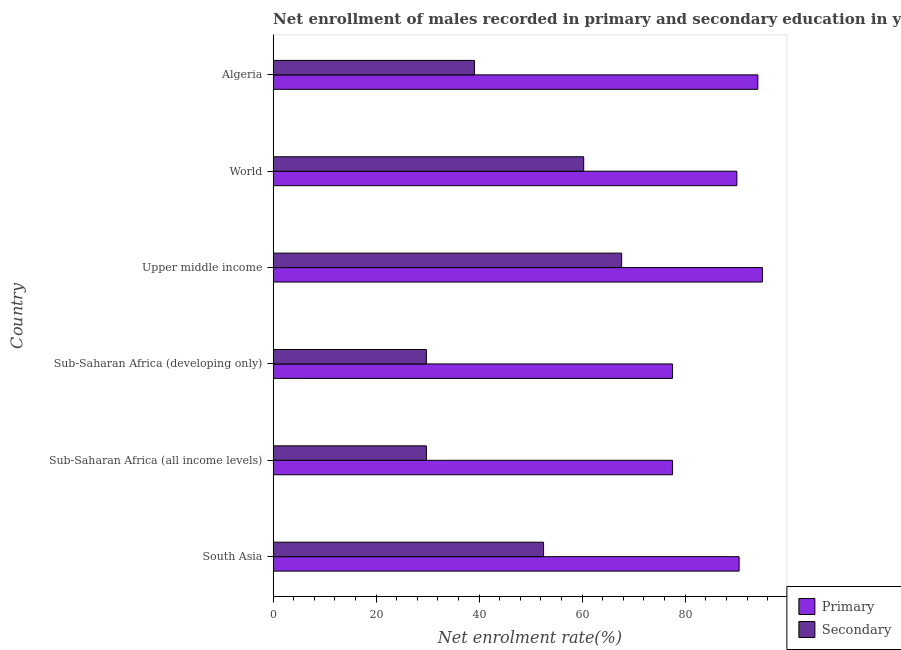How many different coloured bars are there?
Your answer should be very brief. 2. Are the number of bars per tick equal to the number of legend labels?
Your answer should be compact. Yes. Are the number of bars on each tick of the Y-axis equal?
Offer a terse response. Yes. How many bars are there on the 6th tick from the top?
Your answer should be compact. 2. How many bars are there on the 1st tick from the bottom?
Your response must be concise. 2. What is the label of the 5th group of bars from the top?
Your response must be concise. Sub-Saharan Africa (all income levels). In how many cases, is the number of bars for a given country not equal to the number of legend labels?
Make the answer very short. 0. What is the enrollment rate in primary education in World?
Your response must be concise. 90.03. Across all countries, what is the maximum enrollment rate in primary education?
Your answer should be very brief. 94.99. Across all countries, what is the minimum enrollment rate in secondary education?
Offer a very short reply. 29.75. In which country was the enrollment rate in secondary education maximum?
Your answer should be compact. Upper middle income. In which country was the enrollment rate in secondary education minimum?
Make the answer very short. Sub-Saharan Africa (developing only). What is the total enrollment rate in secondary education in the graph?
Provide a short and direct response. 279.05. What is the difference between the enrollment rate in secondary education in Algeria and that in Sub-Saharan Africa (developing only)?
Your answer should be compact. 9.33. What is the difference between the enrollment rate in primary education in Sub-Saharan Africa (developing only) and the enrollment rate in secondary education in Upper middle income?
Offer a very short reply. 9.88. What is the average enrollment rate in secondary education per country?
Your response must be concise. 46.51. What is the difference between the enrollment rate in primary education and enrollment rate in secondary education in Sub-Saharan Africa (all income levels)?
Your answer should be very brief. 47.77. What is the ratio of the enrollment rate in secondary education in Algeria to that in Upper middle income?
Your answer should be compact. 0.58. Is the enrollment rate in secondary education in Sub-Saharan Africa (all income levels) less than that in Sub-Saharan Africa (developing only)?
Provide a succinct answer. No. Is the difference between the enrollment rate in secondary education in Upper middle income and World greater than the difference between the enrollment rate in primary education in Upper middle income and World?
Make the answer very short. Yes. What is the difference between the highest and the second highest enrollment rate in secondary education?
Keep it short and to the point. 7.37. What is the difference between the highest and the lowest enrollment rate in secondary education?
Your answer should be very brief. 37.91. What does the 2nd bar from the top in South Asia represents?
Make the answer very short. Primary. What does the 1st bar from the bottom in South Asia represents?
Your answer should be very brief. Primary. How many bars are there?
Offer a terse response. 12. What is the difference between two consecutive major ticks on the X-axis?
Provide a short and direct response. 20. Are the values on the major ticks of X-axis written in scientific E-notation?
Offer a terse response. No. Where does the legend appear in the graph?
Keep it short and to the point. Bottom right. What is the title of the graph?
Offer a very short reply. Net enrollment of males recorded in primary and secondary education in year 2007. What is the label or title of the X-axis?
Offer a very short reply. Net enrolment rate(%). What is the Net enrolment rate(%) of Primary in South Asia?
Give a very brief answer. 90.47. What is the Net enrolment rate(%) in Secondary in South Asia?
Ensure brevity in your answer.  52.5. What is the Net enrolment rate(%) of Primary in Sub-Saharan Africa (all income levels)?
Your answer should be very brief. 77.53. What is the Net enrolment rate(%) in Secondary in Sub-Saharan Africa (all income levels)?
Keep it short and to the point. 29.75. What is the Net enrolment rate(%) in Primary in Sub-Saharan Africa (developing only)?
Your answer should be very brief. 77.54. What is the Net enrolment rate(%) of Secondary in Sub-Saharan Africa (developing only)?
Your answer should be compact. 29.75. What is the Net enrolment rate(%) in Primary in Upper middle income?
Keep it short and to the point. 94.99. What is the Net enrolment rate(%) of Secondary in Upper middle income?
Make the answer very short. 67.66. What is the Net enrolment rate(%) of Primary in World?
Your answer should be compact. 90.03. What is the Net enrolment rate(%) in Secondary in World?
Your response must be concise. 60.29. What is the Net enrolment rate(%) of Primary in Algeria?
Offer a terse response. 94.11. What is the Net enrolment rate(%) of Secondary in Algeria?
Make the answer very short. 39.08. Across all countries, what is the maximum Net enrolment rate(%) in Primary?
Your response must be concise. 94.99. Across all countries, what is the maximum Net enrolment rate(%) in Secondary?
Your answer should be compact. 67.66. Across all countries, what is the minimum Net enrolment rate(%) in Primary?
Ensure brevity in your answer.  77.53. Across all countries, what is the minimum Net enrolment rate(%) in Secondary?
Give a very brief answer. 29.75. What is the total Net enrolment rate(%) of Primary in the graph?
Your answer should be very brief. 524.66. What is the total Net enrolment rate(%) in Secondary in the graph?
Offer a terse response. 279.05. What is the difference between the Net enrolment rate(%) in Primary in South Asia and that in Sub-Saharan Africa (all income levels)?
Offer a very short reply. 12.94. What is the difference between the Net enrolment rate(%) of Secondary in South Asia and that in Sub-Saharan Africa (all income levels)?
Your response must be concise. 22.75. What is the difference between the Net enrolment rate(%) of Primary in South Asia and that in Sub-Saharan Africa (developing only)?
Ensure brevity in your answer.  12.93. What is the difference between the Net enrolment rate(%) of Secondary in South Asia and that in Sub-Saharan Africa (developing only)?
Make the answer very short. 22.75. What is the difference between the Net enrolment rate(%) in Primary in South Asia and that in Upper middle income?
Give a very brief answer. -4.52. What is the difference between the Net enrolment rate(%) in Secondary in South Asia and that in Upper middle income?
Your response must be concise. -15.16. What is the difference between the Net enrolment rate(%) in Primary in South Asia and that in World?
Give a very brief answer. 0.44. What is the difference between the Net enrolment rate(%) in Secondary in South Asia and that in World?
Ensure brevity in your answer.  -7.79. What is the difference between the Net enrolment rate(%) of Primary in South Asia and that in Algeria?
Provide a short and direct response. -3.64. What is the difference between the Net enrolment rate(%) of Secondary in South Asia and that in Algeria?
Give a very brief answer. 13.42. What is the difference between the Net enrolment rate(%) in Primary in Sub-Saharan Africa (all income levels) and that in Sub-Saharan Africa (developing only)?
Provide a succinct answer. -0.01. What is the difference between the Net enrolment rate(%) in Primary in Sub-Saharan Africa (all income levels) and that in Upper middle income?
Offer a very short reply. -17.46. What is the difference between the Net enrolment rate(%) in Secondary in Sub-Saharan Africa (all income levels) and that in Upper middle income?
Make the answer very short. -37.9. What is the difference between the Net enrolment rate(%) in Primary in Sub-Saharan Africa (all income levels) and that in World?
Your answer should be very brief. -12.5. What is the difference between the Net enrolment rate(%) of Secondary in Sub-Saharan Africa (all income levels) and that in World?
Give a very brief answer. -30.54. What is the difference between the Net enrolment rate(%) of Primary in Sub-Saharan Africa (all income levels) and that in Algeria?
Provide a short and direct response. -16.58. What is the difference between the Net enrolment rate(%) in Secondary in Sub-Saharan Africa (all income levels) and that in Algeria?
Ensure brevity in your answer.  -9.33. What is the difference between the Net enrolment rate(%) of Primary in Sub-Saharan Africa (developing only) and that in Upper middle income?
Provide a succinct answer. -17.45. What is the difference between the Net enrolment rate(%) of Secondary in Sub-Saharan Africa (developing only) and that in Upper middle income?
Your response must be concise. -37.91. What is the difference between the Net enrolment rate(%) in Primary in Sub-Saharan Africa (developing only) and that in World?
Ensure brevity in your answer.  -12.49. What is the difference between the Net enrolment rate(%) in Secondary in Sub-Saharan Africa (developing only) and that in World?
Provide a succinct answer. -30.54. What is the difference between the Net enrolment rate(%) in Primary in Sub-Saharan Africa (developing only) and that in Algeria?
Offer a terse response. -16.57. What is the difference between the Net enrolment rate(%) of Secondary in Sub-Saharan Africa (developing only) and that in Algeria?
Make the answer very short. -9.33. What is the difference between the Net enrolment rate(%) in Primary in Upper middle income and that in World?
Offer a terse response. 4.96. What is the difference between the Net enrolment rate(%) in Secondary in Upper middle income and that in World?
Keep it short and to the point. 7.37. What is the difference between the Net enrolment rate(%) of Primary in Upper middle income and that in Algeria?
Make the answer very short. 0.88. What is the difference between the Net enrolment rate(%) of Secondary in Upper middle income and that in Algeria?
Provide a short and direct response. 28.57. What is the difference between the Net enrolment rate(%) of Primary in World and that in Algeria?
Provide a succinct answer. -4.08. What is the difference between the Net enrolment rate(%) of Secondary in World and that in Algeria?
Give a very brief answer. 21.21. What is the difference between the Net enrolment rate(%) of Primary in South Asia and the Net enrolment rate(%) of Secondary in Sub-Saharan Africa (all income levels)?
Your answer should be very brief. 60.71. What is the difference between the Net enrolment rate(%) of Primary in South Asia and the Net enrolment rate(%) of Secondary in Sub-Saharan Africa (developing only)?
Offer a very short reply. 60.71. What is the difference between the Net enrolment rate(%) of Primary in South Asia and the Net enrolment rate(%) of Secondary in Upper middle income?
Ensure brevity in your answer.  22.81. What is the difference between the Net enrolment rate(%) of Primary in South Asia and the Net enrolment rate(%) of Secondary in World?
Your answer should be compact. 30.17. What is the difference between the Net enrolment rate(%) in Primary in South Asia and the Net enrolment rate(%) in Secondary in Algeria?
Your response must be concise. 51.38. What is the difference between the Net enrolment rate(%) in Primary in Sub-Saharan Africa (all income levels) and the Net enrolment rate(%) in Secondary in Sub-Saharan Africa (developing only)?
Ensure brevity in your answer.  47.77. What is the difference between the Net enrolment rate(%) in Primary in Sub-Saharan Africa (all income levels) and the Net enrolment rate(%) in Secondary in Upper middle income?
Keep it short and to the point. 9.87. What is the difference between the Net enrolment rate(%) in Primary in Sub-Saharan Africa (all income levels) and the Net enrolment rate(%) in Secondary in World?
Offer a terse response. 17.23. What is the difference between the Net enrolment rate(%) in Primary in Sub-Saharan Africa (all income levels) and the Net enrolment rate(%) in Secondary in Algeria?
Your answer should be compact. 38.44. What is the difference between the Net enrolment rate(%) of Primary in Sub-Saharan Africa (developing only) and the Net enrolment rate(%) of Secondary in Upper middle income?
Your answer should be compact. 9.88. What is the difference between the Net enrolment rate(%) in Primary in Sub-Saharan Africa (developing only) and the Net enrolment rate(%) in Secondary in World?
Provide a short and direct response. 17.24. What is the difference between the Net enrolment rate(%) of Primary in Sub-Saharan Africa (developing only) and the Net enrolment rate(%) of Secondary in Algeria?
Ensure brevity in your answer.  38.45. What is the difference between the Net enrolment rate(%) of Primary in Upper middle income and the Net enrolment rate(%) of Secondary in World?
Ensure brevity in your answer.  34.7. What is the difference between the Net enrolment rate(%) of Primary in Upper middle income and the Net enrolment rate(%) of Secondary in Algeria?
Provide a succinct answer. 55.91. What is the difference between the Net enrolment rate(%) of Primary in World and the Net enrolment rate(%) of Secondary in Algeria?
Provide a succinct answer. 50.94. What is the average Net enrolment rate(%) in Primary per country?
Keep it short and to the point. 87.44. What is the average Net enrolment rate(%) of Secondary per country?
Give a very brief answer. 46.51. What is the difference between the Net enrolment rate(%) of Primary and Net enrolment rate(%) of Secondary in South Asia?
Give a very brief answer. 37.97. What is the difference between the Net enrolment rate(%) in Primary and Net enrolment rate(%) in Secondary in Sub-Saharan Africa (all income levels)?
Ensure brevity in your answer.  47.77. What is the difference between the Net enrolment rate(%) of Primary and Net enrolment rate(%) of Secondary in Sub-Saharan Africa (developing only)?
Offer a very short reply. 47.78. What is the difference between the Net enrolment rate(%) in Primary and Net enrolment rate(%) in Secondary in Upper middle income?
Your answer should be very brief. 27.33. What is the difference between the Net enrolment rate(%) of Primary and Net enrolment rate(%) of Secondary in World?
Provide a succinct answer. 29.74. What is the difference between the Net enrolment rate(%) of Primary and Net enrolment rate(%) of Secondary in Algeria?
Your response must be concise. 55.02. What is the ratio of the Net enrolment rate(%) of Primary in South Asia to that in Sub-Saharan Africa (all income levels)?
Offer a very short reply. 1.17. What is the ratio of the Net enrolment rate(%) in Secondary in South Asia to that in Sub-Saharan Africa (all income levels)?
Offer a terse response. 1.76. What is the ratio of the Net enrolment rate(%) of Primary in South Asia to that in Sub-Saharan Africa (developing only)?
Keep it short and to the point. 1.17. What is the ratio of the Net enrolment rate(%) in Secondary in South Asia to that in Sub-Saharan Africa (developing only)?
Your answer should be compact. 1.76. What is the ratio of the Net enrolment rate(%) in Secondary in South Asia to that in Upper middle income?
Provide a short and direct response. 0.78. What is the ratio of the Net enrolment rate(%) in Primary in South Asia to that in World?
Offer a terse response. 1. What is the ratio of the Net enrolment rate(%) of Secondary in South Asia to that in World?
Give a very brief answer. 0.87. What is the ratio of the Net enrolment rate(%) in Primary in South Asia to that in Algeria?
Your answer should be compact. 0.96. What is the ratio of the Net enrolment rate(%) of Secondary in South Asia to that in Algeria?
Your response must be concise. 1.34. What is the ratio of the Net enrolment rate(%) in Primary in Sub-Saharan Africa (all income levels) to that in Sub-Saharan Africa (developing only)?
Provide a succinct answer. 1. What is the ratio of the Net enrolment rate(%) of Primary in Sub-Saharan Africa (all income levels) to that in Upper middle income?
Your answer should be very brief. 0.82. What is the ratio of the Net enrolment rate(%) of Secondary in Sub-Saharan Africa (all income levels) to that in Upper middle income?
Your answer should be very brief. 0.44. What is the ratio of the Net enrolment rate(%) of Primary in Sub-Saharan Africa (all income levels) to that in World?
Keep it short and to the point. 0.86. What is the ratio of the Net enrolment rate(%) of Secondary in Sub-Saharan Africa (all income levels) to that in World?
Ensure brevity in your answer.  0.49. What is the ratio of the Net enrolment rate(%) in Primary in Sub-Saharan Africa (all income levels) to that in Algeria?
Make the answer very short. 0.82. What is the ratio of the Net enrolment rate(%) in Secondary in Sub-Saharan Africa (all income levels) to that in Algeria?
Provide a short and direct response. 0.76. What is the ratio of the Net enrolment rate(%) in Primary in Sub-Saharan Africa (developing only) to that in Upper middle income?
Offer a very short reply. 0.82. What is the ratio of the Net enrolment rate(%) of Secondary in Sub-Saharan Africa (developing only) to that in Upper middle income?
Make the answer very short. 0.44. What is the ratio of the Net enrolment rate(%) of Primary in Sub-Saharan Africa (developing only) to that in World?
Your response must be concise. 0.86. What is the ratio of the Net enrolment rate(%) in Secondary in Sub-Saharan Africa (developing only) to that in World?
Offer a very short reply. 0.49. What is the ratio of the Net enrolment rate(%) of Primary in Sub-Saharan Africa (developing only) to that in Algeria?
Make the answer very short. 0.82. What is the ratio of the Net enrolment rate(%) of Secondary in Sub-Saharan Africa (developing only) to that in Algeria?
Ensure brevity in your answer.  0.76. What is the ratio of the Net enrolment rate(%) in Primary in Upper middle income to that in World?
Offer a terse response. 1.06. What is the ratio of the Net enrolment rate(%) of Secondary in Upper middle income to that in World?
Provide a succinct answer. 1.12. What is the ratio of the Net enrolment rate(%) in Primary in Upper middle income to that in Algeria?
Make the answer very short. 1.01. What is the ratio of the Net enrolment rate(%) of Secondary in Upper middle income to that in Algeria?
Offer a very short reply. 1.73. What is the ratio of the Net enrolment rate(%) of Primary in World to that in Algeria?
Offer a terse response. 0.96. What is the ratio of the Net enrolment rate(%) in Secondary in World to that in Algeria?
Offer a very short reply. 1.54. What is the difference between the highest and the second highest Net enrolment rate(%) in Primary?
Your response must be concise. 0.88. What is the difference between the highest and the second highest Net enrolment rate(%) in Secondary?
Offer a very short reply. 7.37. What is the difference between the highest and the lowest Net enrolment rate(%) of Primary?
Ensure brevity in your answer.  17.46. What is the difference between the highest and the lowest Net enrolment rate(%) in Secondary?
Your response must be concise. 37.91. 